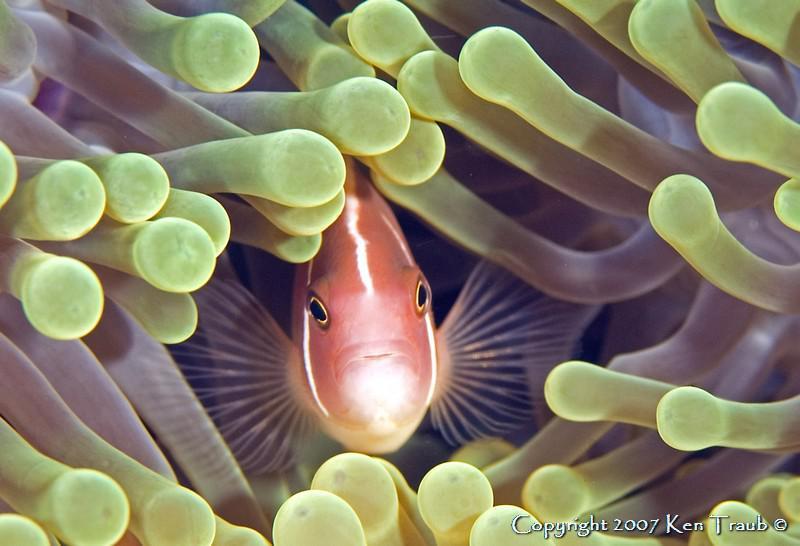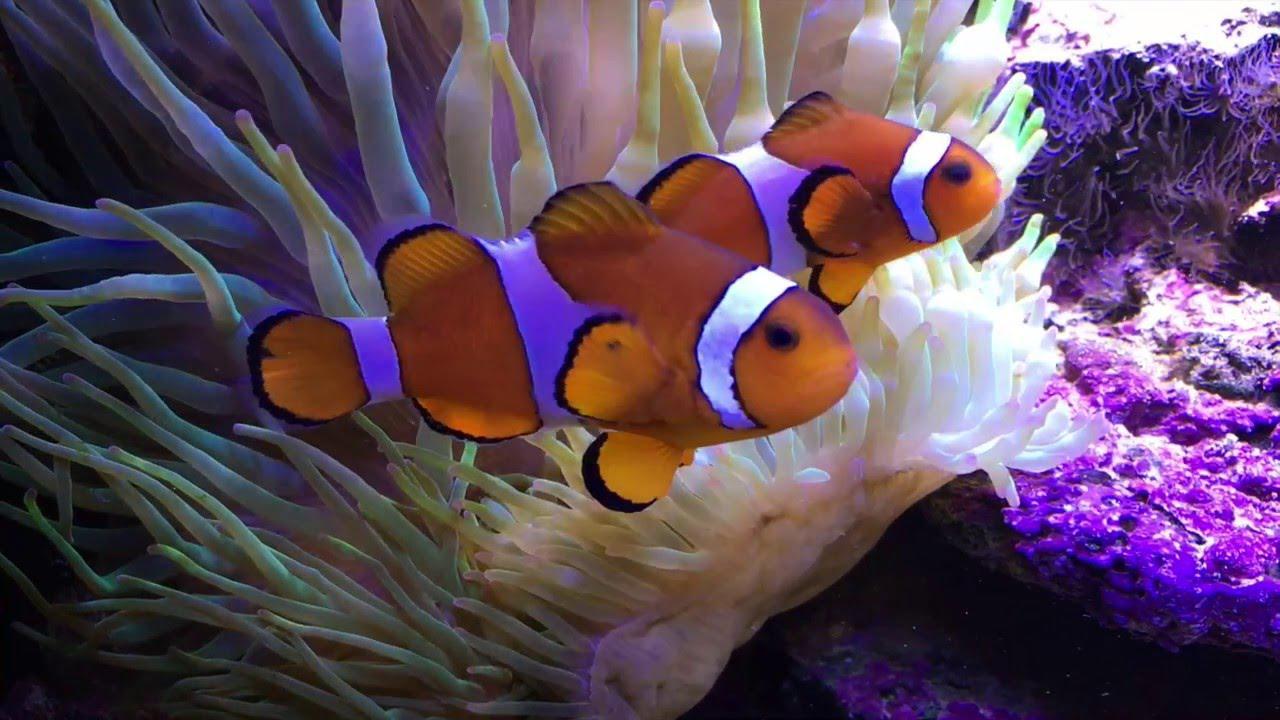The first image is the image on the left, the second image is the image on the right. Assess this claim about the two images: "there is only clownfish on the right image". Correct or not? Answer yes or no. No. 